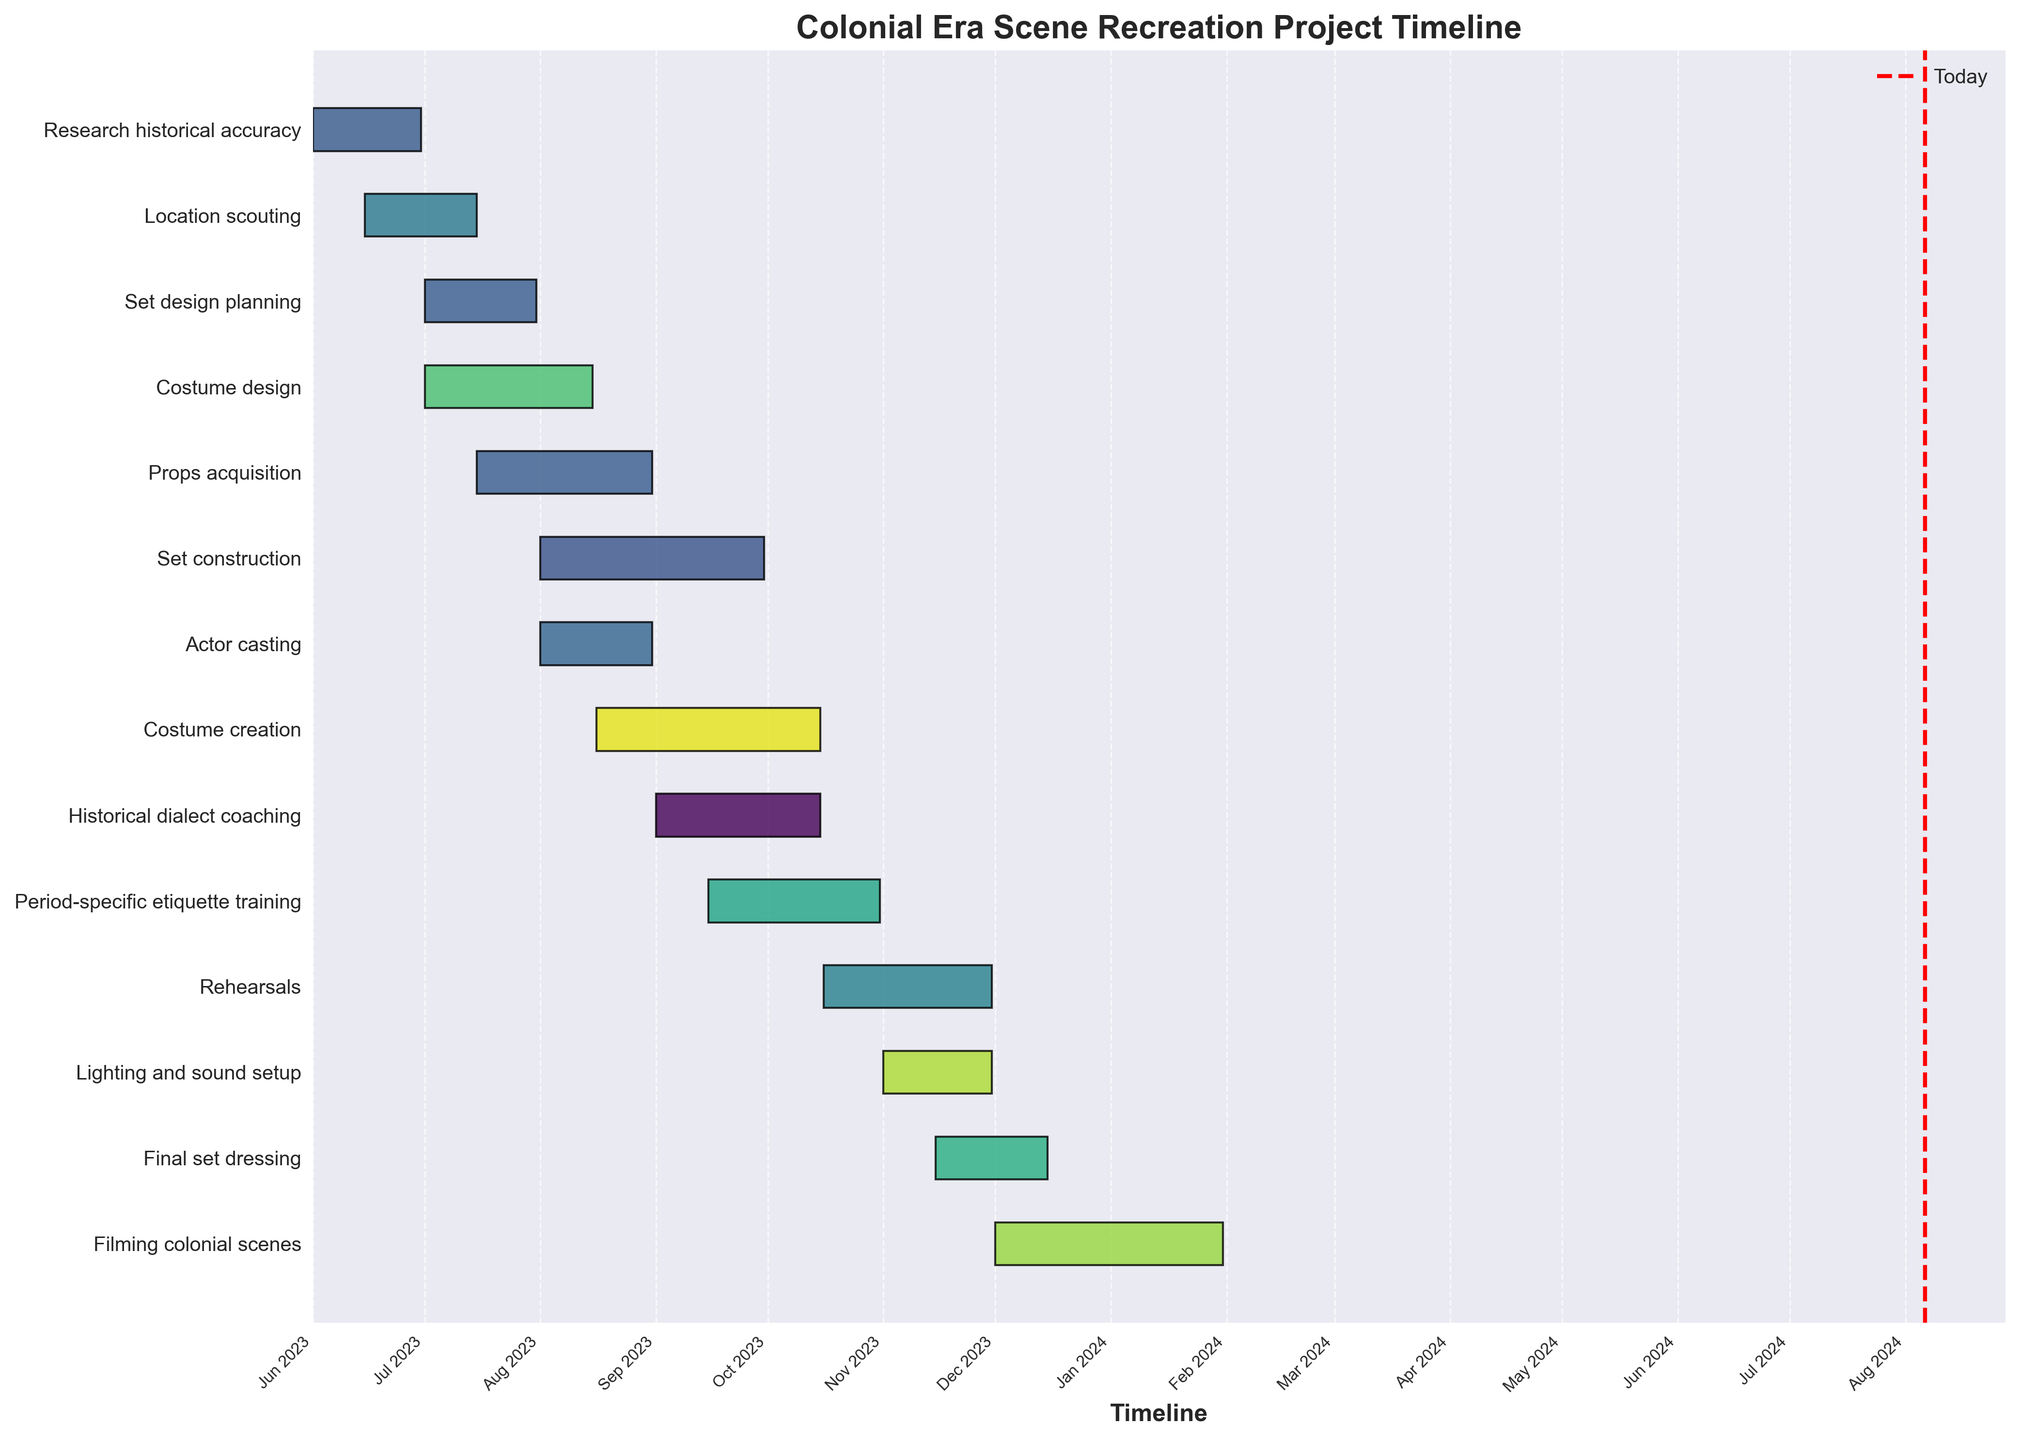1. What is the title of the Gantt chart? The title of the Gantt chart is located at the top of the plot and provides a summary of the project.
Answer: Colonial Era Scene Recreation Project Timeline 2. How long does the 'Research historical accuracy' task take? To find the duration, look at the start and end dates for the 'Research historical accuracy' task in the chart, which are 2023-06-01 to 2023-06-30. Calculating the difference gives the total number of days.
Answer: 30 days 3. Which task has the longest duration? By examining the lengths of the horizontal bars, the task with the longest bar is the one with the longest duration.
Answer: Filming colonial scenes 4. When does the 'Set construction' phase start and end? Check the positions of the 'Set construction' bar to determine its start and end points.
Answer: Starts on 2023-08-01 and ends on 2023-09-30 5. Is the 'Actor casting' phase completed before 'Actor casting' starts? Compare the start-date positions of 'Actor casting' and 'Historical dialect coaching' to see if one precedes the other.
Answer: Yes, 'Actor casting' ends on 2023-08-31 and 'Historical dialect coaching' starts on 2023-09-01 6. Which tasks overlap in August 2023? Identify the bars that span across August 2023 and check their names.
Answer: Location scouting, Set design planning, Costume design, Props acquisition, Set construction, Costume creation, and Actor casting 7. How many days does the 'Historical dialect coaching' task take? Look at the duration of the 'Historical dialect coaching' task by checking its start and end dates: 2023-09-01 to 2023-10-15. Calculate the total number of days.
Answer: 45 days 8. What task begins immediately after 'Costume creation'? Check the timeline to see which task follows the end date of 'Costume creation' on 2023-10-15.
Answer: Rehearsals 9. During which month does the 'Final set dressing' phase overlap with 'Filming colonial scenes'? Examine the timeline to find periods where both 'Final set dressing' and 'Filming colonial scenes' are occurring simultaneously.
Answer: December 2023 10. Are there any tasks that start before June 2023? Check the start dates of all tasks to see if there are any that begin before June 2023.
Answer: No 